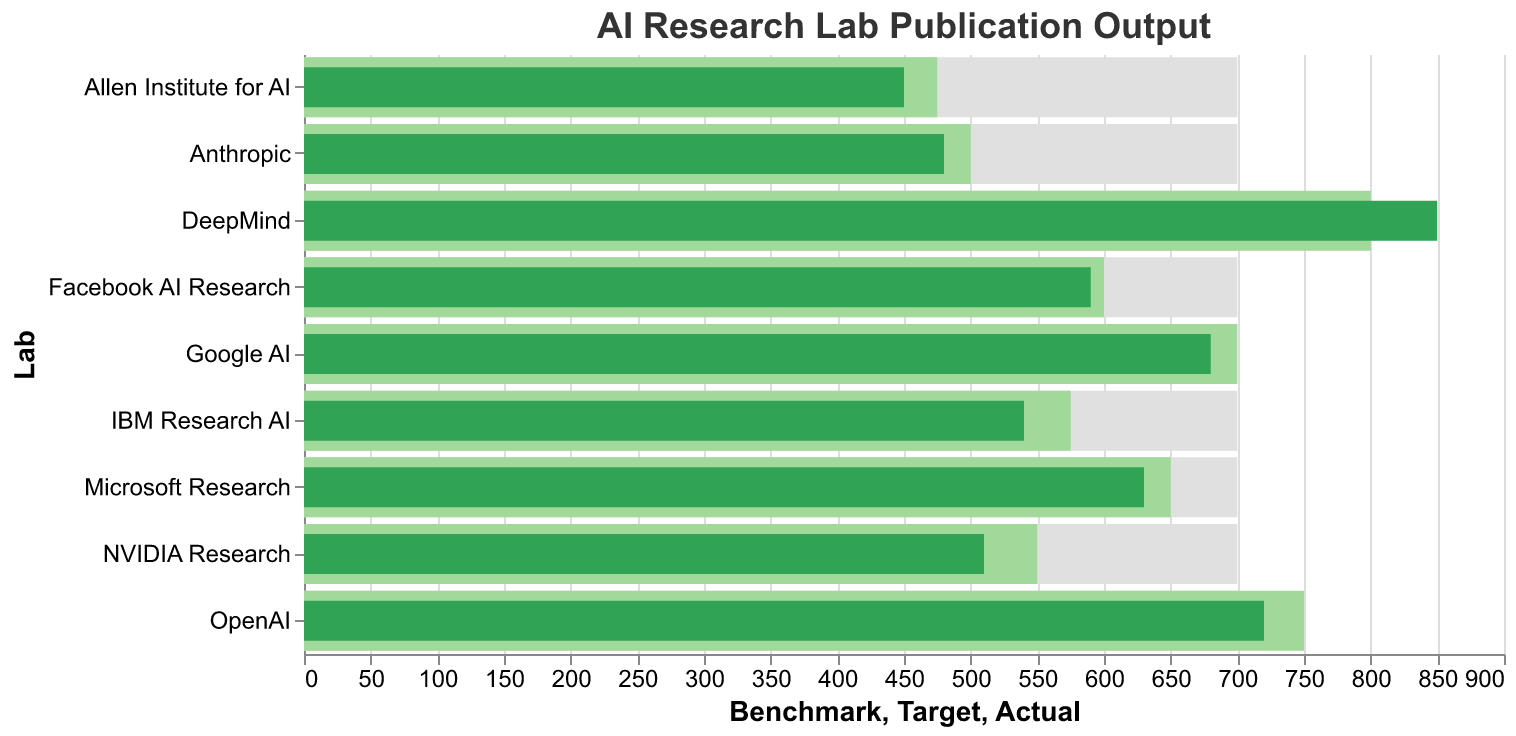What is the title of the figure? The title of a figure is usually found at the top. Here, it indicates the theme of the chart, which is about the publication output of AI research labs.
Answer: AI Research Lab Publication Output Which lab has the highest actual publication output? To find the lab with the highest actual output, locate the tallest bar in the green series. Here, DeepMind has the tallest green bar representing 850 publications.
Answer: DeepMind How does the actual output of OpenAI compare to its target? Compare the green bar for OpenAI (actual output) with the lighter green bar (target). OpenAI's actual output is 720 while its target is 750, showing that it didn't meet the target by 30 publications.
Answer: 720 vs 750 Which labs exceeded their publication target? To determine this, compare the length of the green bars (actual) to the lighter green bars (target) for each lab. Only DeepMind's green bar extends beyond its target bar.
Answer: DeepMind What is the difference between the actual and benchmark publication output for Microsoft Research? To solve this, find Microsoft Research and compare the green bar (actual output of 630) with the gray bar (benchmark of 700). The difference is 700 - 630 = 70 publications.
Answer: 70 publications Which lab has the lowest actual publication output? Locate the shortest green bar in the figure. Here, the shortest green bar corresponds to the Allen Institute for AI, which has 450 actual publications.
Answer: Allen Institute for AI For how many labs is the target publication output less than the benchmark? Count the number of labs where the length of the lighter green bar (target) is less than the length of the gray bar (benchmark). All nine labs have targets less than the benchmark, which is consistently 700 for all labs.
Answer: 9 labs Which labs have an actual publication output greater than the industry benchmark? Identify the labs where the length of the green bar (actual) is longer than the gray bar (benchmark). Only DeepMind has an actual publication output (850) exceeding the benchmark (700).
Answer: DeepMind How much more is DeepMind's actual publication output than Facebook AI Research's actual output? Find the green bars for both DeepMind (850) and Facebook AI Research (590). The difference is 850 - 590 = 260 publications.
Answer: 260 publications What is the median target publication output for all labs? To find the median, list all target outputs in ascending order: 475, 500, 550, 575, 600, 650, 700, 750, 800. The median value is the middle one in this sorted list, which is 600.
Answer: 600 